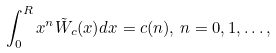Convert formula to latex. <formula><loc_0><loc_0><loc_500><loc_500>\int _ { 0 } ^ { R } x ^ { n } { \tilde { W } } _ { c } ( x ) d x = c ( n ) , \, n = 0 , 1 , \dots ,</formula> 